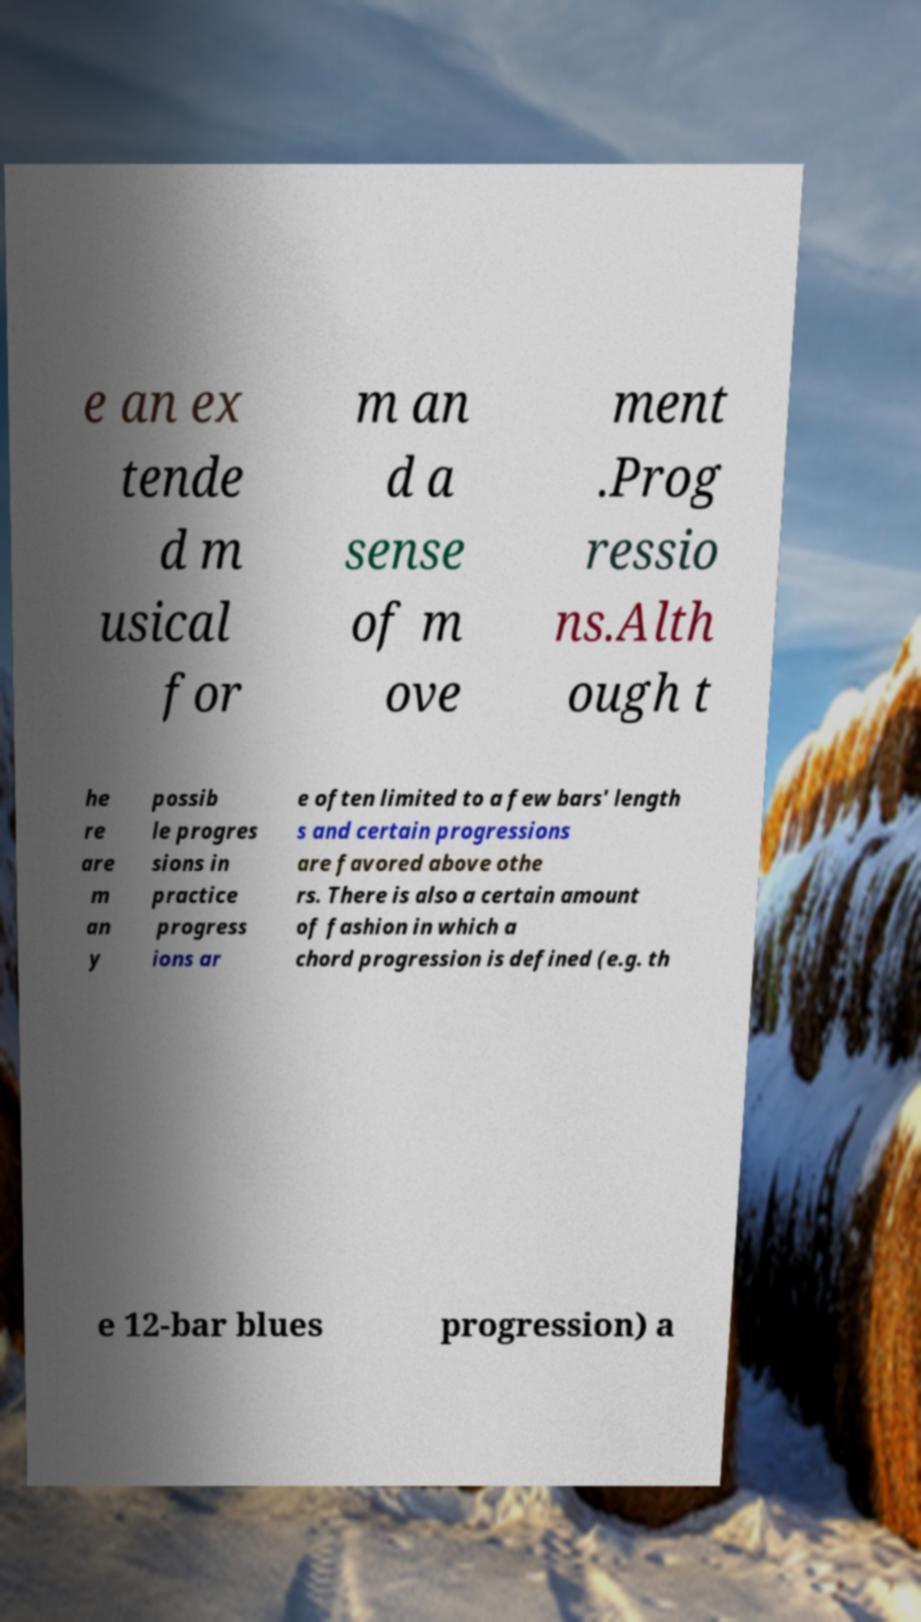Could you assist in decoding the text presented in this image and type it out clearly? e an ex tende d m usical for m an d a sense of m ove ment .Prog ressio ns.Alth ough t he re are m an y possib le progres sions in practice progress ions ar e often limited to a few bars' length s and certain progressions are favored above othe rs. There is also a certain amount of fashion in which a chord progression is defined (e.g. th e 12-bar blues progression) a 